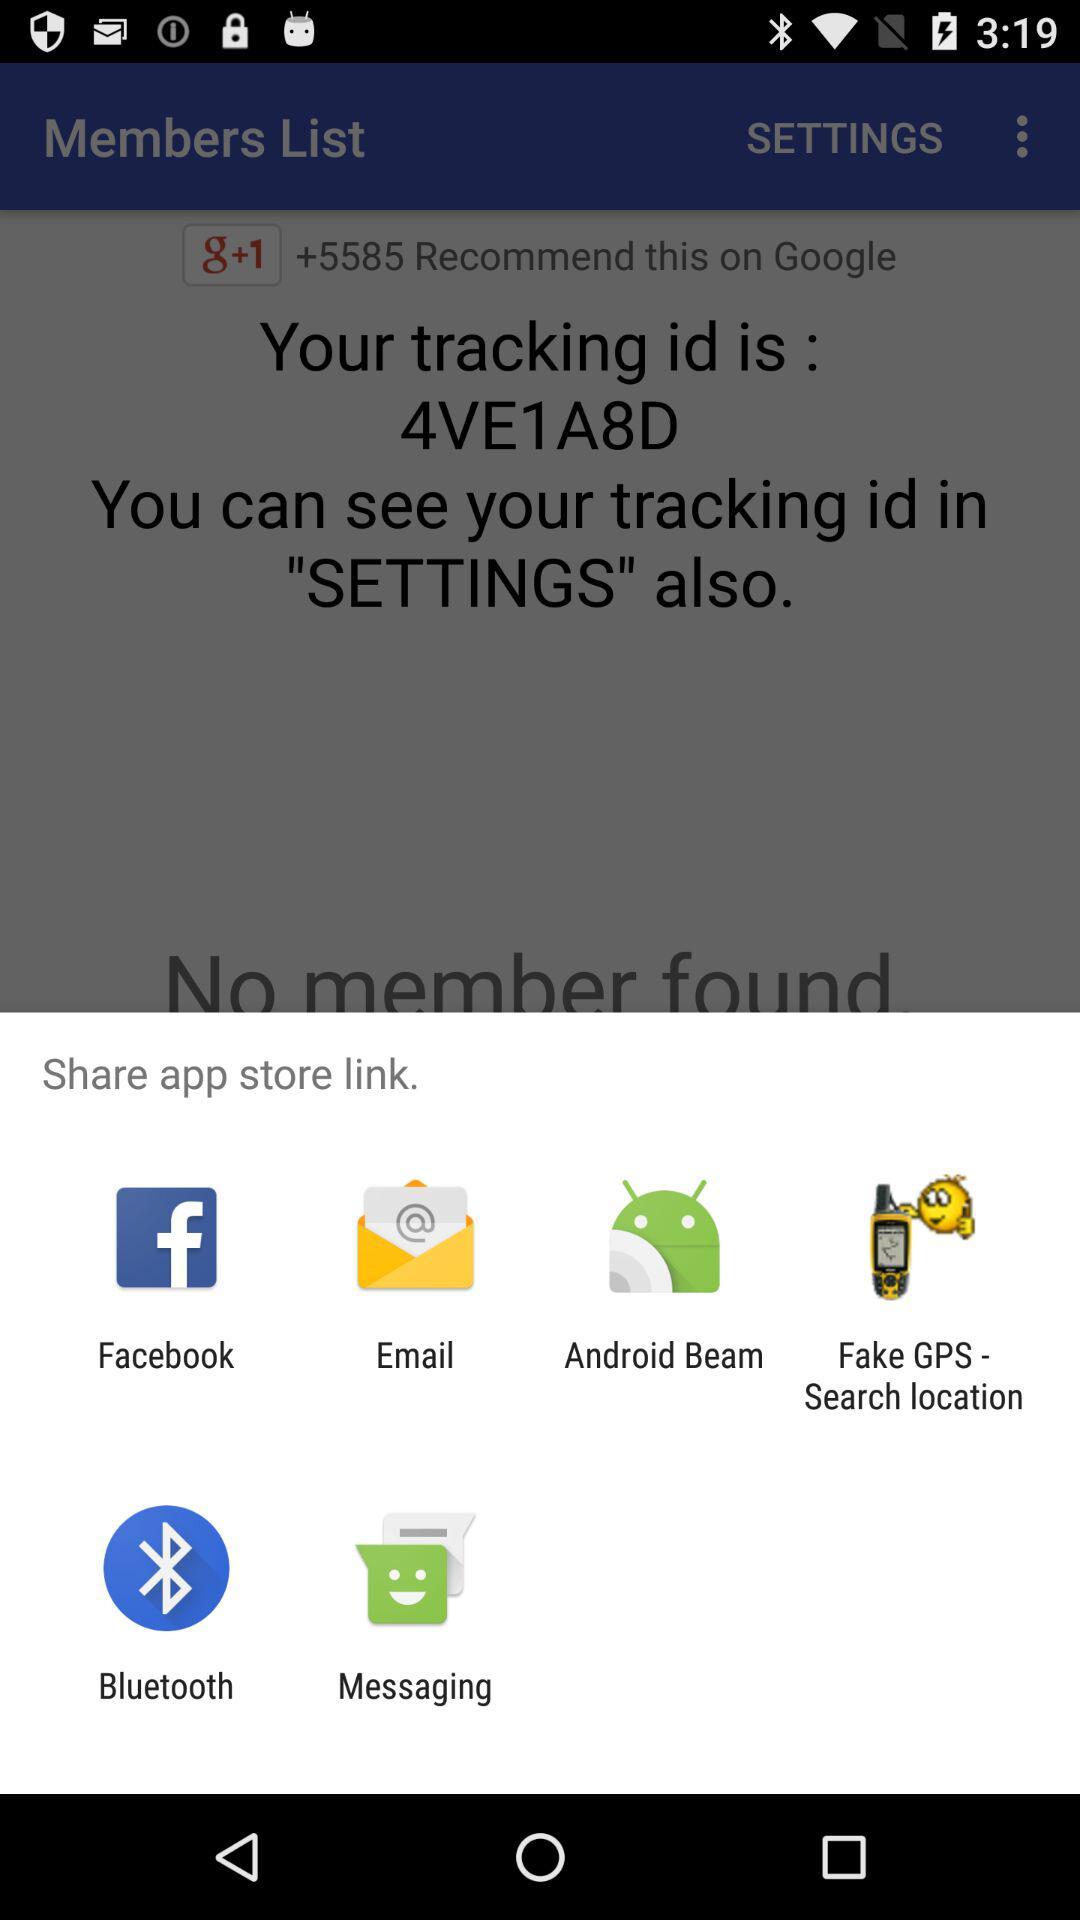How many notifications are there in "SETTINGS"?
When the provided information is insufficient, respond with <no answer>. <no answer> 